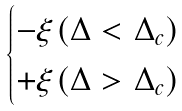Convert formula to latex. <formula><loc_0><loc_0><loc_500><loc_500>\begin{cases} - \xi ( \Delta < \Delta _ { c } ) \\ + \xi ( \Delta > \Delta _ { c } ) \end{cases}</formula> 